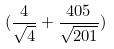Convert formula to latex. <formula><loc_0><loc_0><loc_500><loc_500>( \frac { 4 } { \sqrt { 4 } } + \frac { 4 0 5 } { \sqrt { 2 0 1 } } )</formula> 